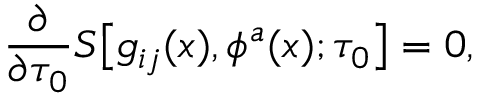<formula> <loc_0><loc_0><loc_500><loc_500>{ \frac { \partial } { \partial \tau _ { 0 } } } S \left [ g _ { i j } ( x ) , \phi ^ { a } ( x ) ; \tau _ { 0 } \right ] = 0 ,</formula> 